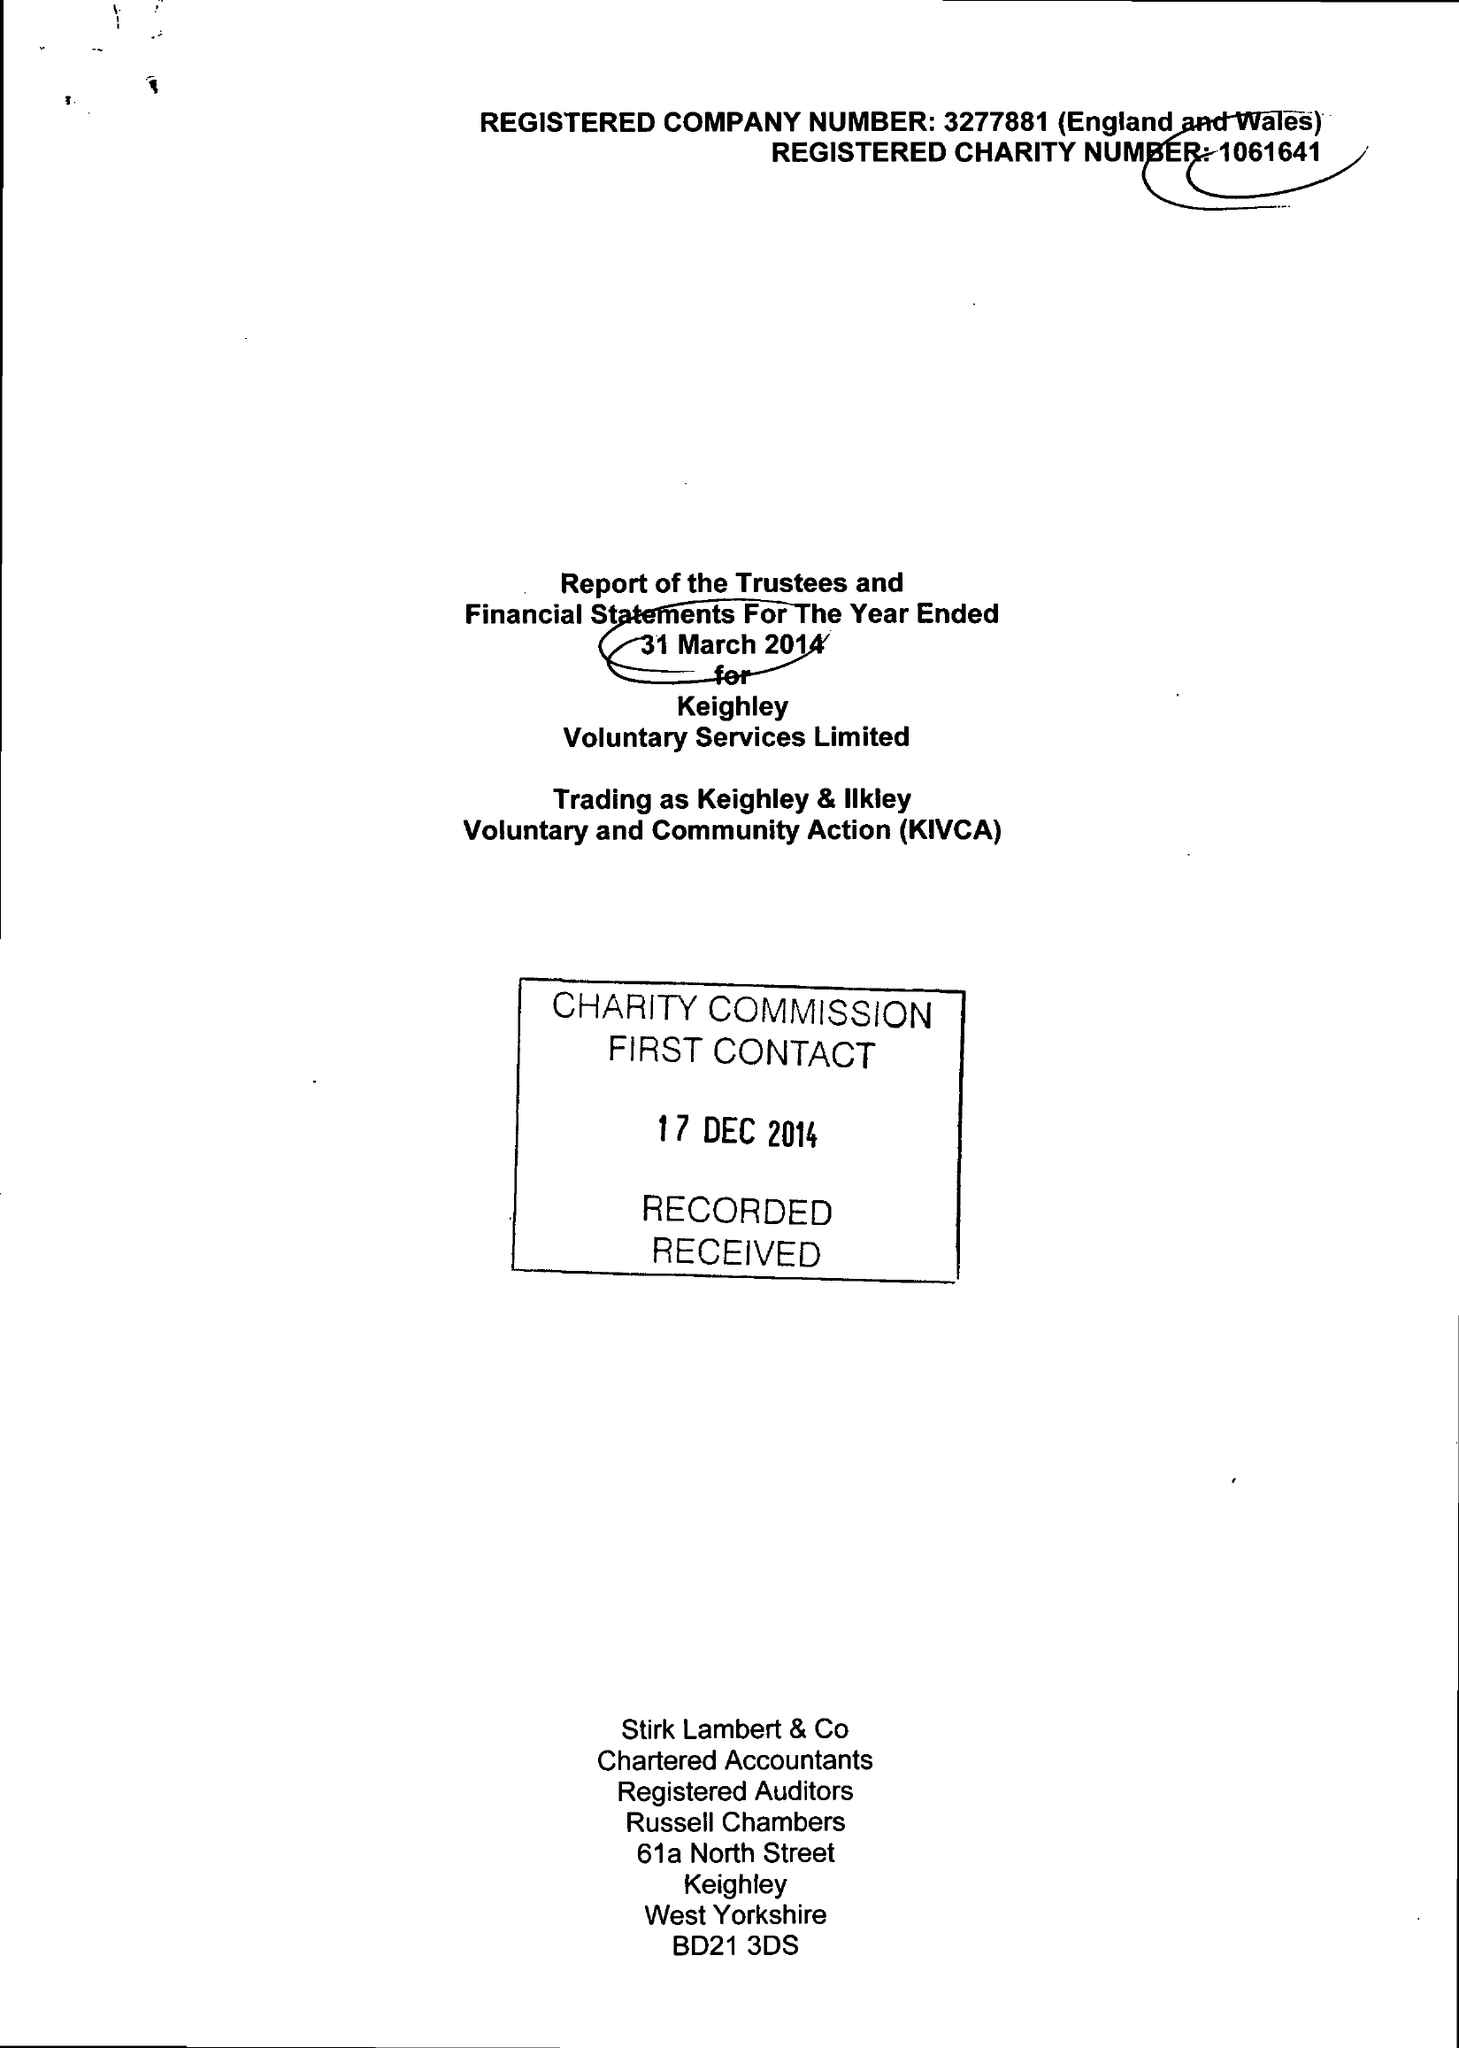What is the value for the income_annually_in_british_pounds?
Answer the question using a single word or phrase. 1035274.00 